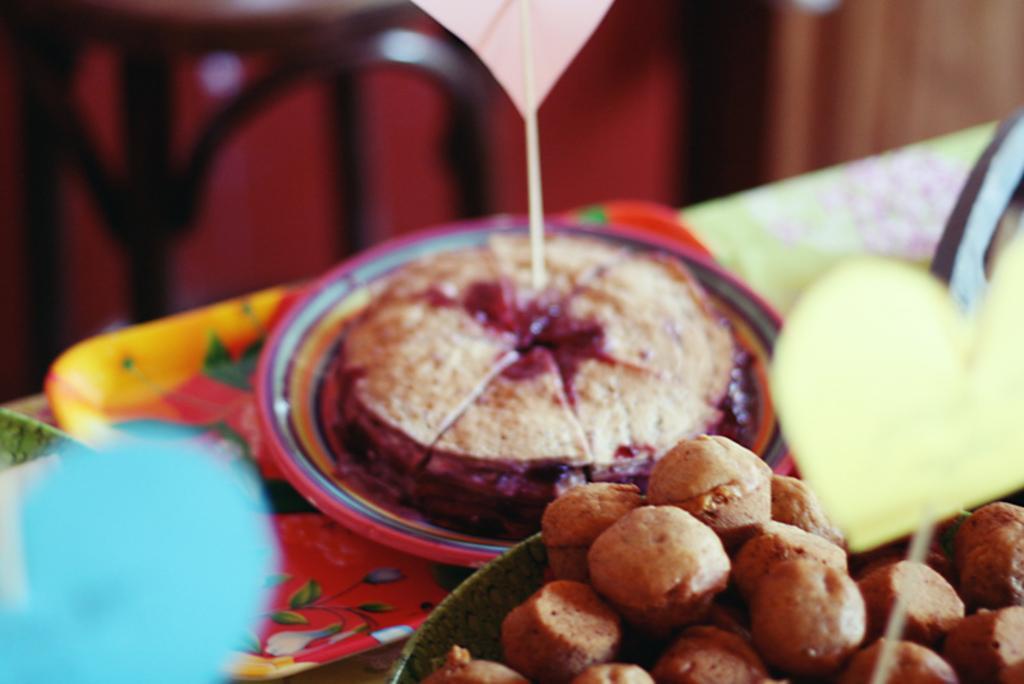Describe this image in one or two sentences. In this image I can see few plates which are red, blue, orange and green in color and on them I can see few food items which are brown and red in color. In the background I can see few other objects which are blurry. 